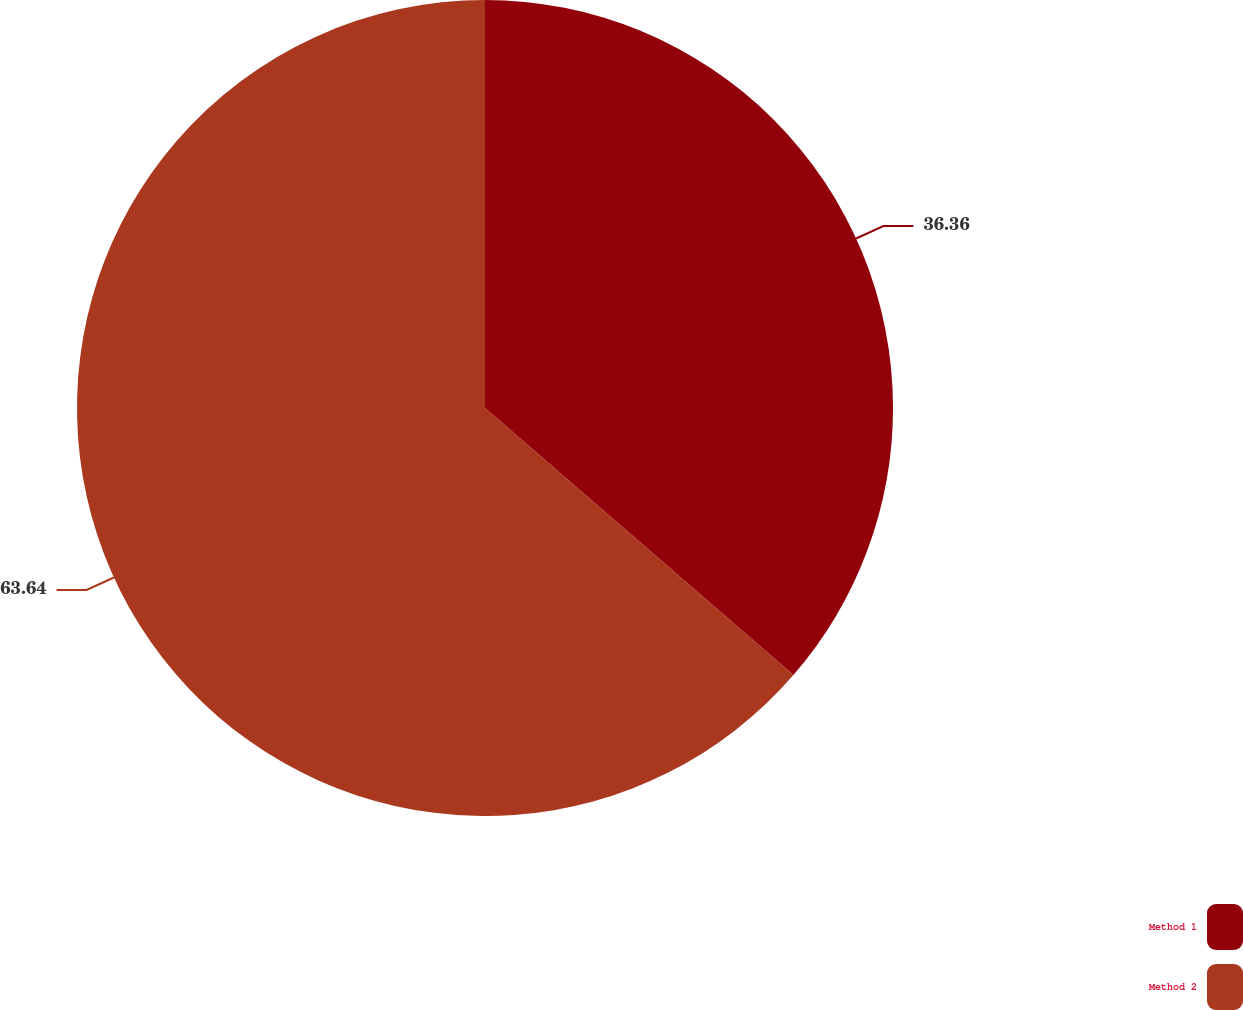Convert chart to OTSL. <chart><loc_0><loc_0><loc_500><loc_500><pie_chart><fcel>Method 1<fcel>Method 2<nl><fcel>36.36%<fcel>63.64%<nl></chart> 